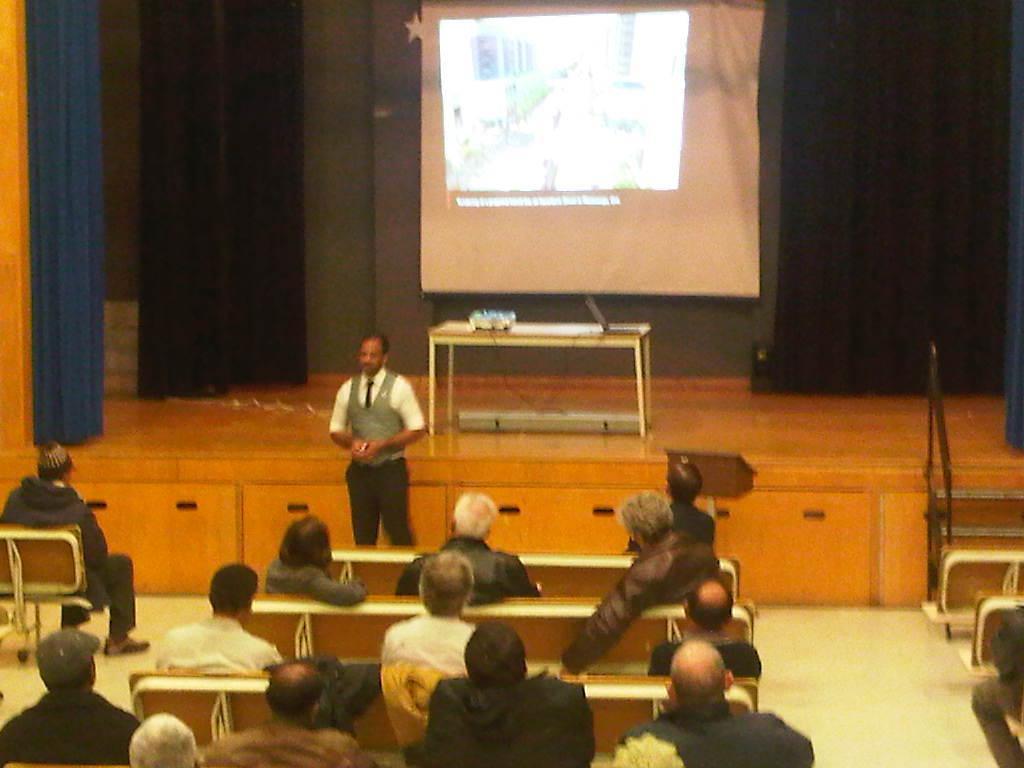Can you describe this image briefly? This image is taken indoors. At the bottom of the image there is a floor and a few people are sitting on the benches. In the background there is a wall with curtains and a projector screen. In the middle of the image a man is standing on the floor and there is a dais with a table on it and on the table there is a laptop and a book. 